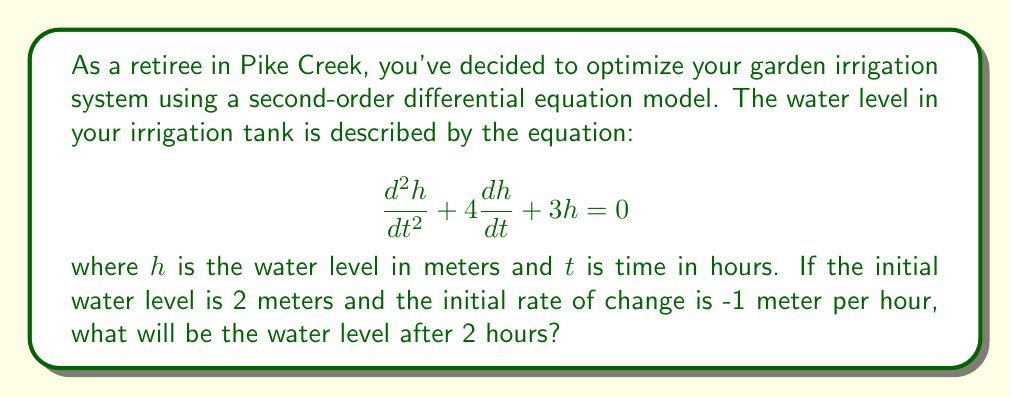Solve this math problem. To solve this problem, we need to follow these steps:

1) The general solution for this second-order linear differential equation is:

   $$h(t) = c_1e^{-t} + c_2e^{-3t}$$

2) We need to find $c_1$ and $c_2$ using the initial conditions:
   
   At $t=0$, $h(0) = 2$ and $h'(0) = -1$

3) Using the first condition:

   $$h(0) = c_1 + c_2 = 2$$

4) For the second condition, we differentiate $h(t)$:

   $$h'(t) = -c_1e^{-t} - 3c_2e^{-3t}$$

   At $t=0$: $h'(0) = -c_1 - 3c_2 = -1$

5) Now we have a system of equations:

   $$c_1 + c_2 = 2$$
   $$c_1 + 3c_2 = 1$$

6) Subtracting the first equation from the second:

   $$2c_2 = -1$$
   $$c_2 = -0.5$$

7) Substituting back:

   $$c_1 + (-0.5) = 2$$
   $$c_1 = 2.5$$

8) Now we have our particular solution:

   $$h(t) = 2.5e^{-t} - 0.5e^{-3t}$$

9) To find the water level after 2 hours, we calculate $h(2)$:

   $$h(2) = 2.5e^{-2} - 0.5e^{-6}$$

10) Evaluating this:

    $$h(2) = 2.5(0.1353) - 0.5(0.0025) = 0.3382 - 0.0012 = 0.3370$$
Answer: The water level after 2 hours will be approximately 0.337 meters. 